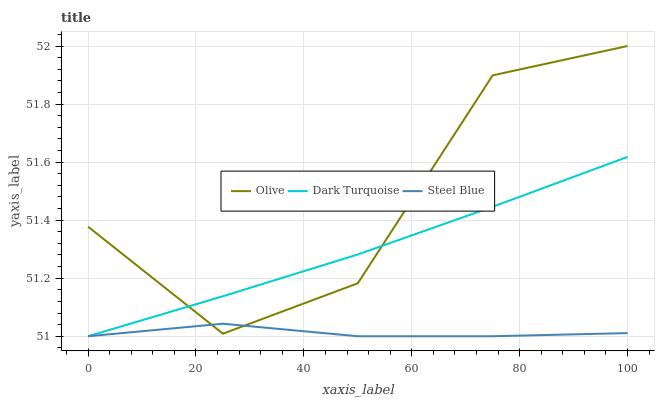Does Steel Blue have the minimum area under the curve?
Answer yes or no. Yes. Does Olive have the maximum area under the curve?
Answer yes or no. Yes. Does Dark Turquoise have the minimum area under the curve?
Answer yes or no. No. Does Dark Turquoise have the maximum area under the curve?
Answer yes or no. No. Is Dark Turquoise the smoothest?
Answer yes or no. Yes. Is Olive the roughest?
Answer yes or no. Yes. Is Steel Blue the smoothest?
Answer yes or no. No. Is Steel Blue the roughest?
Answer yes or no. No. Does Dark Turquoise have the lowest value?
Answer yes or no. Yes. Does Olive have the highest value?
Answer yes or no. Yes. Does Dark Turquoise have the highest value?
Answer yes or no. No. Does Dark Turquoise intersect Olive?
Answer yes or no. Yes. Is Dark Turquoise less than Olive?
Answer yes or no. No. Is Dark Turquoise greater than Olive?
Answer yes or no. No. 